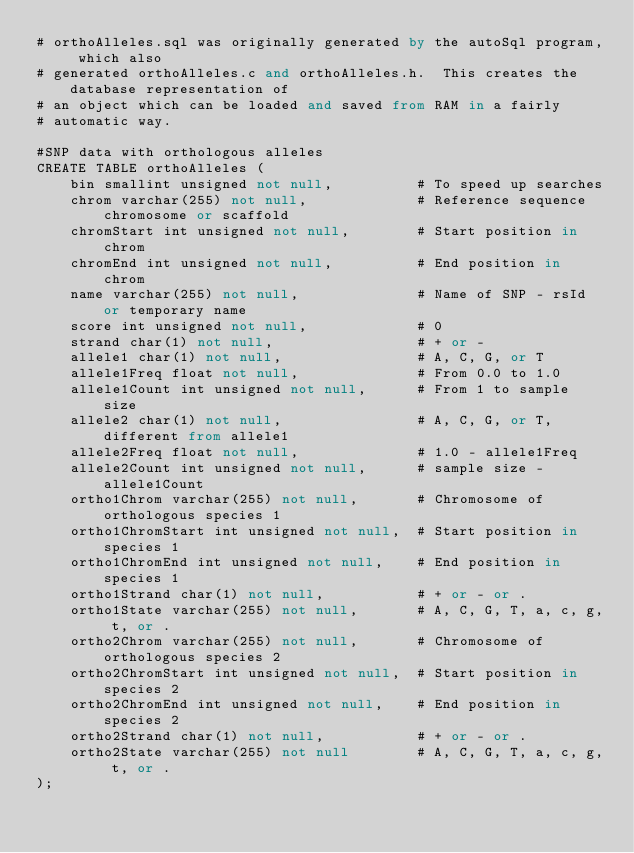<code> <loc_0><loc_0><loc_500><loc_500><_SQL_># orthoAlleles.sql was originally generated by the autoSql program, which also 
# generated orthoAlleles.c and orthoAlleles.h.  This creates the database representation of
# an object which can be loaded and saved from RAM in a fairly 
# automatic way.

#SNP data with orthologous alleles
CREATE TABLE orthoAlleles (
    bin smallint unsigned not null,          # To speed up searches
    chrom varchar(255) not null,             # Reference sequence chromosome or scaffold
    chromStart int unsigned not null,        # Start position in chrom
    chromEnd int unsigned not null,          # End position in chrom
    name varchar(255) not null,              # Name of SNP - rsId or temporary name
    score int unsigned not null,             # 0
    strand char(1) not null,                 # + or -
    allele1 char(1) not null,                # A, C, G, or T
    allele1Freq float not null,              # From 0.0 to 1.0
    allele1Count int unsigned not null,      # From 1 to sample size
    allele2 char(1) not null,                # A, C, G, or T, different from allele1
    allele2Freq float not null,              # 1.0 - allele1Freq
    allele2Count int unsigned not null,      # sample size - allele1Count
    ortho1Chrom varchar(255) not null,       # Chromosome of orthologous species 1
    ortho1ChromStart int unsigned not null,  # Start position in species 1
    ortho1ChromEnd int unsigned not null,    # End position in species 1
    ortho1Strand char(1) not null,           # + or - or .
    ortho1State varchar(255) not null,       # A, C, G, T, a, c, g, t, or .
    ortho2Chrom varchar(255) not null,       # Chromosome of orthologous species 2
    ortho2ChromStart int unsigned not null,  # Start position in species 2
    ortho2ChromEnd int unsigned not null,    # End position in species 2
    ortho2Strand char(1) not null,           # + or - or .
    ortho2State varchar(255) not null        # A, C, G, T, a, c, g, t, or .
);
</code> 